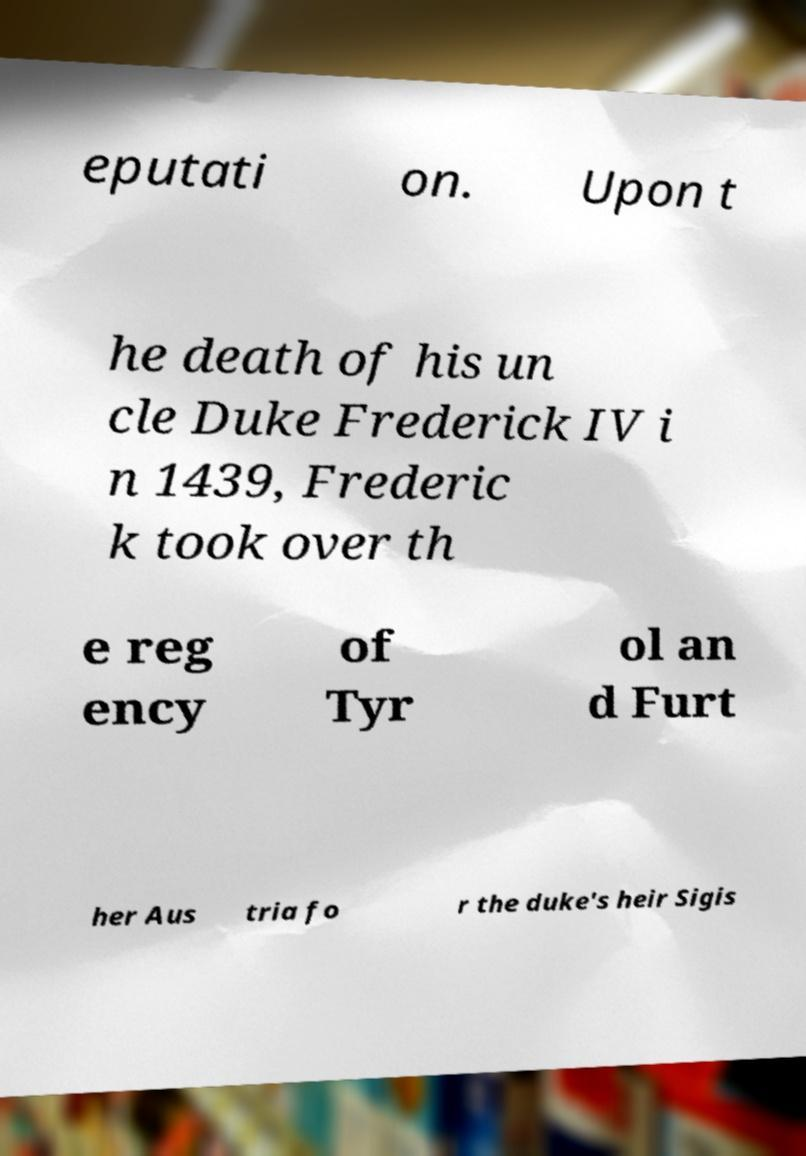Please identify and transcribe the text found in this image. eputati on. Upon t he death of his un cle Duke Frederick IV i n 1439, Frederic k took over th e reg ency of Tyr ol an d Furt her Aus tria fo r the duke's heir Sigis 